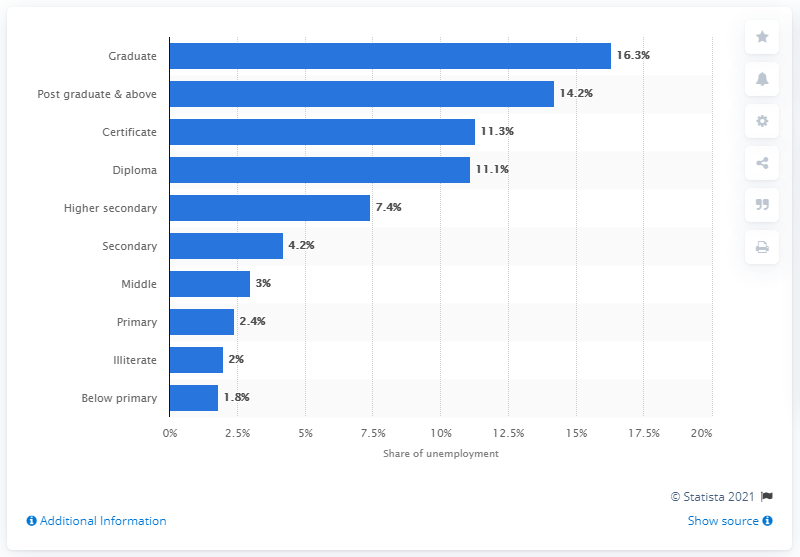What is the trend in unemployment rates across education levels as depicted in the image? The trend in the image suggests that unemployment rates tend to decrease with lower educational levels. While graduates have the highest rate at 16.3%, the rates gradually decline as the education level drops, with the lowest unemployment rate seen in individuals with below primary education at 1.8%. 